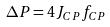Convert formula to latex. <formula><loc_0><loc_0><loc_500><loc_500>\Delta P = 4 J _ { C P } f _ { C P }</formula> 